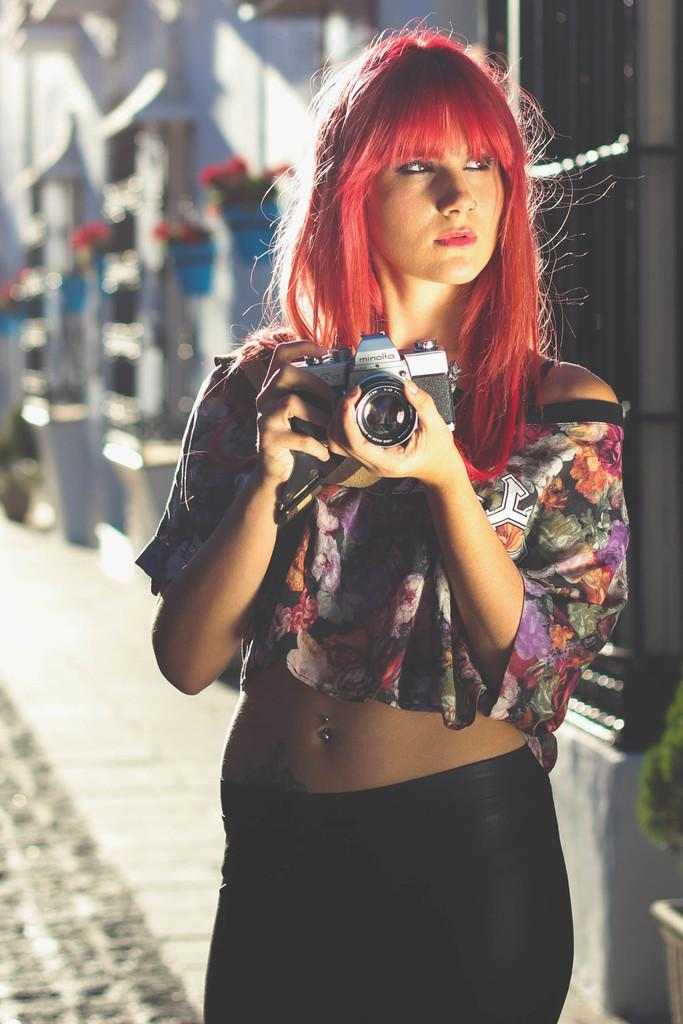Who is the main subject in the image? There is a woman in the image. What is the woman doing in the image? The woman is standing and holding a camera. What can be seen in the background of the image? There is a road in the background of the image. What is the color of the road? The road is white in color. How many sheep are present in the image? There are no sheep present in the image. What expertise does the woman have in photography, as seen in the image? The image does not provide any information about the woman's expertise in photography. 